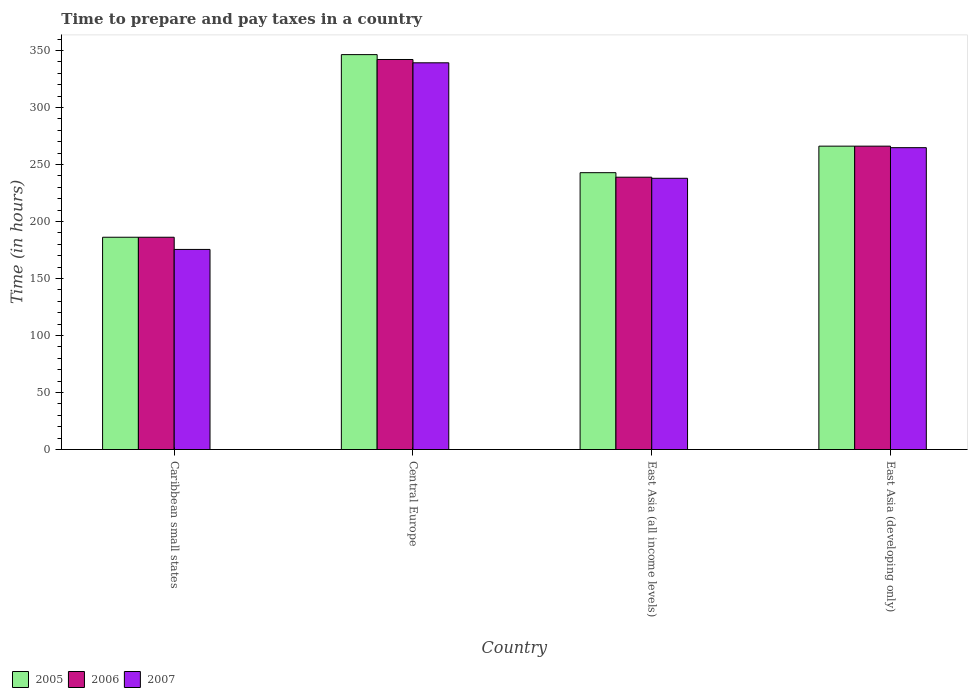How many groups of bars are there?
Your response must be concise. 4. Are the number of bars per tick equal to the number of legend labels?
Provide a short and direct response. Yes. Are the number of bars on each tick of the X-axis equal?
Your response must be concise. Yes. How many bars are there on the 2nd tick from the right?
Provide a succinct answer. 3. What is the label of the 3rd group of bars from the left?
Make the answer very short. East Asia (all income levels). What is the number of hours required to prepare and pay taxes in 2006 in East Asia (developing only)?
Offer a very short reply. 266.08. Across all countries, what is the maximum number of hours required to prepare and pay taxes in 2006?
Keep it short and to the point. 342.09. Across all countries, what is the minimum number of hours required to prepare and pay taxes in 2007?
Provide a short and direct response. 175.5. In which country was the number of hours required to prepare and pay taxes in 2005 maximum?
Make the answer very short. Central Europe. In which country was the number of hours required to prepare and pay taxes in 2005 minimum?
Your answer should be compact. Caribbean small states. What is the total number of hours required to prepare and pay taxes in 2007 in the graph?
Make the answer very short. 1017.33. What is the difference between the number of hours required to prepare and pay taxes in 2006 in Central Europe and that in East Asia (developing only)?
Provide a succinct answer. 76.01. What is the difference between the number of hours required to prepare and pay taxes in 2005 in Central Europe and the number of hours required to prepare and pay taxes in 2007 in Caribbean small states?
Make the answer very short. 170.86. What is the average number of hours required to prepare and pay taxes in 2006 per country?
Keep it short and to the point. 258.3. What is the difference between the number of hours required to prepare and pay taxes of/in 2007 and number of hours required to prepare and pay taxes of/in 2005 in Central Europe?
Provide a succinct answer. -7.18. What is the ratio of the number of hours required to prepare and pay taxes in 2007 in Caribbean small states to that in Central Europe?
Offer a very short reply. 0.52. What is the difference between the highest and the second highest number of hours required to prepare and pay taxes in 2007?
Give a very brief answer. -74.43. What is the difference between the highest and the lowest number of hours required to prepare and pay taxes in 2005?
Your answer should be compact. 160.18. Is the sum of the number of hours required to prepare and pay taxes in 2007 in Caribbean small states and East Asia (developing only) greater than the maximum number of hours required to prepare and pay taxes in 2006 across all countries?
Your answer should be very brief. Yes. What does the 1st bar from the right in Caribbean small states represents?
Ensure brevity in your answer.  2007. How many countries are there in the graph?
Your response must be concise. 4. Does the graph contain any zero values?
Provide a succinct answer. No. Does the graph contain grids?
Offer a very short reply. No. How are the legend labels stacked?
Keep it short and to the point. Horizontal. What is the title of the graph?
Offer a very short reply. Time to prepare and pay taxes in a country. Does "1990" appear as one of the legend labels in the graph?
Keep it short and to the point. No. What is the label or title of the Y-axis?
Offer a very short reply. Time (in hours). What is the Time (in hours) of 2005 in Caribbean small states?
Give a very brief answer. 186.18. What is the Time (in hours) of 2006 in Caribbean small states?
Keep it short and to the point. 186.18. What is the Time (in hours) of 2007 in Caribbean small states?
Your answer should be compact. 175.5. What is the Time (in hours) in 2005 in Central Europe?
Provide a succinct answer. 346.36. What is the Time (in hours) of 2006 in Central Europe?
Give a very brief answer. 342.09. What is the Time (in hours) of 2007 in Central Europe?
Keep it short and to the point. 339.18. What is the Time (in hours) of 2005 in East Asia (all income levels)?
Offer a very short reply. 242.81. What is the Time (in hours) in 2006 in East Asia (all income levels)?
Your answer should be very brief. 238.86. What is the Time (in hours) in 2007 in East Asia (all income levels)?
Provide a short and direct response. 237.9. What is the Time (in hours) in 2005 in East Asia (developing only)?
Your answer should be very brief. 266.08. What is the Time (in hours) in 2006 in East Asia (developing only)?
Your answer should be compact. 266.08. What is the Time (in hours) of 2007 in East Asia (developing only)?
Ensure brevity in your answer.  264.75. Across all countries, what is the maximum Time (in hours) in 2005?
Offer a terse response. 346.36. Across all countries, what is the maximum Time (in hours) in 2006?
Offer a very short reply. 342.09. Across all countries, what is the maximum Time (in hours) of 2007?
Your answer should be very brief. 339.18. Across all countries, what is the minimum Time (in hours) of 2005?
Offer a very short reply. 186.18. Across all countries, what is the minimum Time (in hours) in 2006?
Offer a very short reply. 186.18. Across all countries, what is the minimum Time (in hours) of 2007?
Provide a succinct answer. 175.5. What is the total Time (in hours) of 2005 in the graph?
Provide a succinct answer. 1041.44. What is the total Time (in hours) in 2006 in the graph?
Your answer should be compact. 1033.22. What is the total Time (in hours) in 2007 in the graph?
Give a very brief answer. 1017.33. What is the difference between the Time (in hours) in 2005 in Caribbean small states and that in Central Europe?
Your response must be concise. -160.18. What is the difference between the Time (in hours) in 2006 in Caribbean small states and that in Central Europe?
Make the answer very short. -155.91. What is the difference between the Time (in hours) in 2007 in Caribbean small states and that in Central Europe?
Make the answer very short. -163.68. What is the difference between the Time (in hours) of 2005 in Caribbean small states and that in East Asia (all income levels)?
Provide a succinct answer. -56.63. What is the difference between the Time (in hours) in 2006 in Caribbean small states and that in East Asia (all income levels)?
Your response must be concise. -52.68. What is the difference between the Time (in hours) of 2007 in Caribbean small states and that in East Asia (all income levels)?
Make the answer very short. -62.4. What is the difference between the Time (in hours) of 2005 in Caribbean small states and that in East Asia (developing only)?
Provide a succinct answer. -79.9. What is the difference between the Time (in hours) in 2006 in Caribbean small states and that in East Asia (developing only)?
Provide a succinct answer. -79.9. What is the difference between the Time (in hours) of 2007 in Caribbean small states and that in East Asia (developing only)?
Your response must be concise. -89.25. What is the difference between the Time (in hours) of 2005 in Central Europe and that in East Asia (all income levels)?
Give a very brief answer. 103.55. What is the difference between the Time (in hours) in 2006 in Central Europe and that in East Asia (all income levels)?
Offer a very short reply. 103.23. What is the difference between the Time (in hours) of 2007 in Central Europe and that in East Asia (all income levels)?
Your response must be concise. 101.28. What is the difference between the Time (in hours) in 2005 in Central Europe and that in East Asia (developing only)?
Offer a terse response. 80.28. What is the difference between the Time (in hours) in 2006 in Central Europe and that in East Asia (developing only)?
Provide a short and direct response. 76.01. What is the difference between the Time (in hours) of 2007 in Central Europe and that in East Asia (developing only)?
Your answer should be compact. 74.43. What is the difference between the Time (in hours) of 2005 in East Asia (all income levels) and that in East Asia (developing only)?
Give a very brief answer. -23.27. What is the difference between the Time (in hours) in 2006 in East Asia (all income levels) and that in East Asia (developing only)?
Your answer should be very brief. -27.22. What is the difference between the Time (in hours) of 2007 in East Asia (all income levels) and that in East Asia (developing only)?
Give a very brief answer. -26.85. What is the difference between the Time (in hours) of 2005 in Caribbean small states and the Time (in hours) of 2006 in Central Europe?
Provide a short and direct response. -155.91. What is the difference between the Time (in hours) of 2005 in Caribbean small states and the Time (in hours) of 2007 in Central Europe?
Offer a very short reply. -153. What is the difference between the Time (in hours) of 2006 in Caribbean small states and the Time (in hours) of 2007 in Central Europe?
Give a very brief answer. -153. What is the difference between the Time (in hours) of 2005 in Caribbean small states and the Time (in hours) of 2006 in East Asia (all income levels)?
Keep it short and to the point. -52.68. What is the difference between the Time (in hours) of 2005 in Caribbean small states and the Time (in hours) of 2007 in East Asia (all income levels)?
Keep it short and to the point. -51.72. What is the difference between the Time (in hours) in 2006 in Caribbean small states and the Time (in hours) in 2007 in East Asia (all income levels)?
Offer a terse response. -51.72. What is the difference between the Time (in hours) of 2005 in Caribbean small states and the Time (in hours) of 2006 in East Asia (developing only)?
Your answer should be compact. -79.9. What is the difference between the Time (in hours) in 2005 in Caribbean small states and the Time (in hours) in 2007 in East Asia (developing only)?
Give a very brief answer. -78.57. What is the difference between the Time (in hours) in 2006 in Caribbean small states and the Time (in hours) in 2007 in East Asia (developing only)?
Ensure brevity in your answer.  -78.57. What is the difference between the Time (in hours) in 2005 in Central Europe and the Time (in hours) in 2006 in East Asia (all income levels)?
Make the answer very short. 107.5. What is the difference between the Time (in hours) in 2005 in Central Europe and the Time (in hours) in 2007 in East Asia (all income levels)?
Make the answer very short. 108.46. What is the difference between the Time (in hours) of 2006 in Central Europe and the Time (in hours) of 2007 in East Asia (all income levels)?
Your response must be concise. 104.19. What is the difference between the Time (in hours) in 2005 in Central Europe and the Time (in hours) in 2006 in East Asia (developing only)?
Provide a short and direct response. 80.28. What is the difference between the Time (in hours) of 2005 in Central Europe and the Time (in hours) of 2007 in East Asia (developing only)?
Keep it short and to the point. 81.61. What is the difference between the Time (in hours) in 2006 in Central Europe and the Time (in hours) in 2007 in East Asia (developing only)?
Offer a very short reply. 77.34. What is the difference between the Time (in hours) in 2005 in East Asia (all income levels) and the Time (in hours) in 2006 in East Asia (developing only)?
Provide a short and direct response. -23.27. What is the difference between the Time (in hours) in 2005 in East Asia (all income levels) and the Time (in hours) in 2007 in East Asia (developing only)?
Offer a terse response. -21.94. What is the difference between the Time (in hours) in 2006 in East Asia (all income levels) and the Time (in hours) in 2007 in East Asia (developing only)?
Your response must be concise. -25.89. What is the average Time (in hours) of 2005 per country?
Provide a short and direct response. 260.36. What is the average Time (in hours) of 2006 per country?
Provide a short and direct response. 258.3. What is the average Time (in hours) of 2007 per country?
Provide a short and direct response. 254.33. What is the difference between the Time (in hours) of 2005 and Time (in hours) of 2007 in Caribbean small states?
Keep it short and to the point. 10.68. What is the difference between the Time (in hours) in 2006 and Time (in hours) in 2007 in Caribbean small states?
Give a very brief answer. 10.68. What is the difference between the Time (in hours) of 2005 and Time (in hours) of 2006 in Central Europe?
Your answer should be compact. 4.27. What is the difference between the Time (in hours) of 2005 and Time (in hours) of 2007 in Central Europe?
Give a very brief answer. 7.18. What is the difference between the Time (in hours) of 2006 and Time (in hours) of 2007 in Central Europe?
Ensure brevity in your answer.  2.91. What is the difference between the Time (in hours) in 2005 and Time (in hours) in 2006 in East Asia (all income levels)?
Your answer should be very brief. 3.95. What is the difference between the Time (in hours) in 2005 and Time (in hours) in 2007 in East Asia (all income levels)?
Provide a succinct answer. 4.91. What is the difference between the Time (in hours) in 2006 and Time (in hours) in 2007 in East Asia (all income levels)?
Make the answer very short. 0.96. What is the difference between the Time (in hours) in 2005 and Time (in hours) in 2007 in East Asia (developing only)?
Your answer should be compact. 1.33. What is the difference between the Time (in hours) in 2006 and Time (in hours) in 2007 in East Asia (developing only)?
Give a very brief answer. 1.33. What is the ratio of the Time (in hours) in 2005 in Caribbean small states to that in Central Europe?
Give a very brief answer. 0.54. What is the ratio of the Time (in hours) in 2006 in Caribbean small states to that in Central Europe?
Keep it short and to the point. 0.54. What is the ratio of the Time (in hours) of 2007 in Caribbean small states to that in Central Europe?
Your answer should be compact. 0.52. What is the ratio of the Time (in hours) in 2005 in Caribbean small states to that in East Asia (all income levels)?
Offer a very short reply. 0.77. What is the ratio of the Time (in hours) of 2006 in Caribbean small states to that in East Asia (all income levels)?
Your answer should be very brief. 0.78. What is the ratio of the Time (in hours) of 2007 in Caribbean small states to that in East Asia (all income levels)?
Make the answer very short. 0.74. What is the ratio of the Time (in hours) of 2005 in Caribbean small states to that in East Asia (developing only)?
Offer a very short reply. 0.7. What is the ratio of the Time (in hours) of 2006 in Caribbean small states to that in East Asia (developing only)?
Your answer should be compact. 0.7. What is the ratio of the Time (in hours) of 2007 in Caribbean small states to that in East Asia (developing only)?
Ensure brevity in your answer.  0.66. What is the ratio of the Time (in hours) of 2005 in Central Europe to that in East Asia (all income levels)?
Provide a short and direct response. 1.43. What is the ratio of the Time (in hours) in 2006 in Central Europe to that in East Asia (all income levels)?
Provide a short and direct response. 1.43. What is the ratio of the Time (in hours) in 2007 in Central Europe to that in East Asia (all income levels)?
Give a very brief answer. 1.43. What is the ratio of the Time (in hours) in 2005 in Central Europe to that in East Asia (developing only)?
Offer a very short reply. 1.3. What is the ratio of the Time (in hours) of 2007 in Central Europe to that in East Asia (developing only)?
Your answer should be very brief. 1.28. What is the ratio of the Time (in hours) of 2005 in East Asia (all income levels) to that in East Asia (developing only)?
Keep it short and to the point. 0.91. What is the ratio of the Time (in hours) of 2006 in East Asia (all income levels) to that in East Asia (developing only)?
Offer a very short reply. 0.9. What is the ratio of the Time (in hours) in 2007 in East Asia (all income levels) to that in East Asia (developing only)?
Your answer should be compact. 0.9. What is the difference between the highest and the second highest Time (in hours) of 2005?
Your answer should be compact. 80.28. What is the difference between the highest and the second highest Time (in hours) of 2006?
Offer a terse response. 76.01. What is the difference between the highest and the second highest Time (in hours) of 2007?
Your answer should be very brief. 74.43. What is the difference between the highest and the lowest Time (in hours) of 2005?
Keep it short and to the point. 160.18. What is the difference between the highest and the lowest Time (in hours) of 2006?
Your answer should be compact. 155.91. What is the difference between the highest and the lowest Time (in hours) in 2007?
Provide a short and direct response. 163.68. 